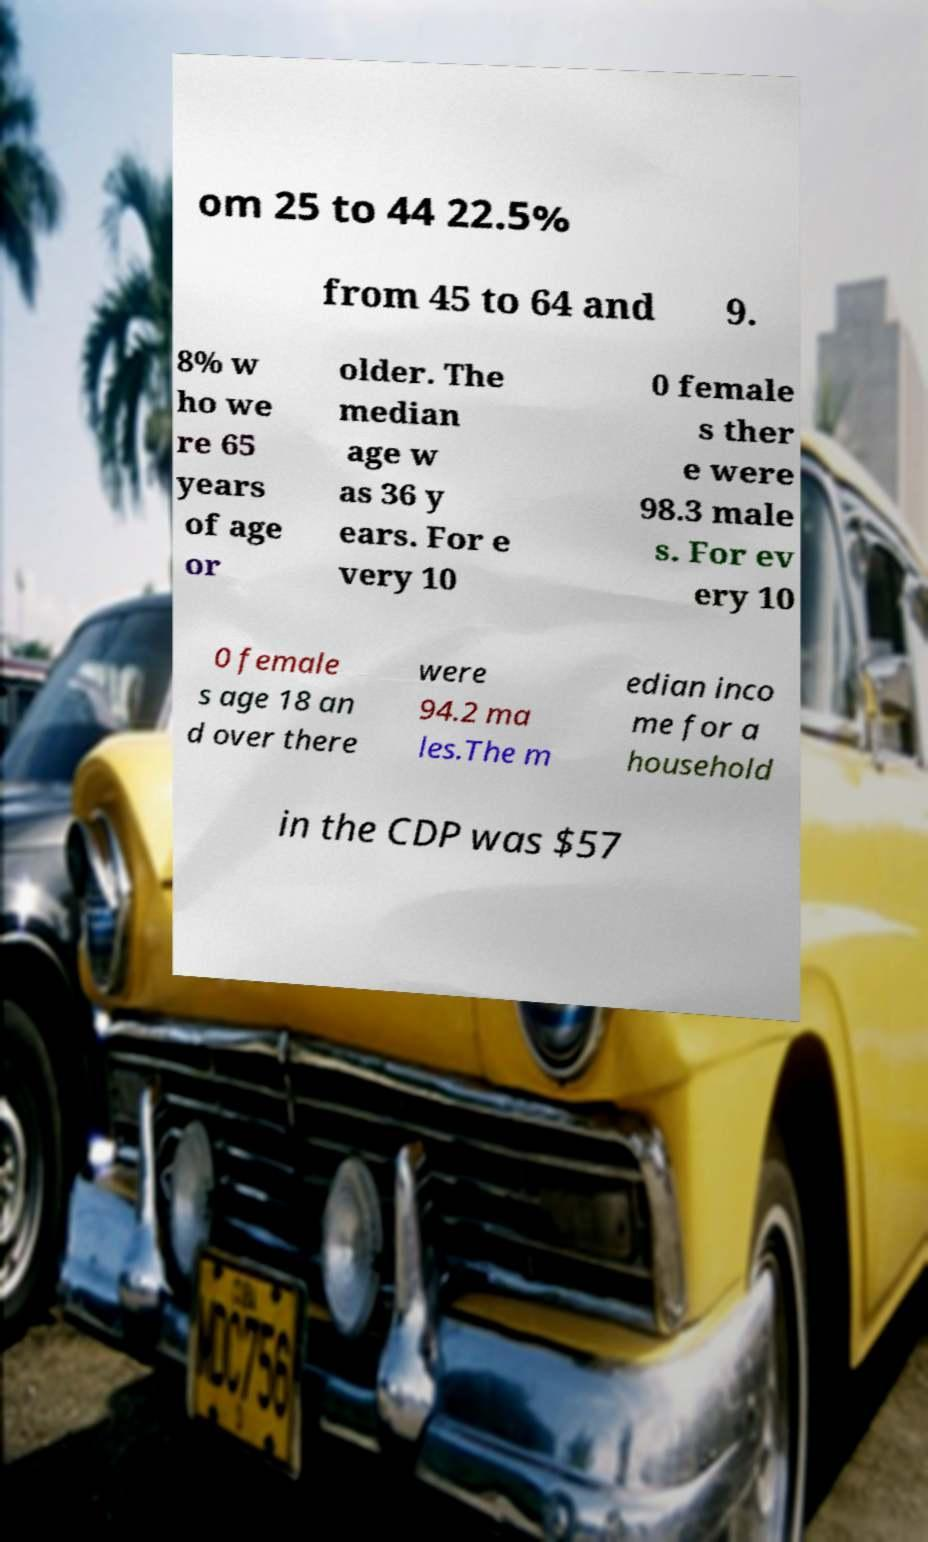Could you assist in decoding the text presented in this image and type it out clearly? om 25 to 44 22.5% from 45 to 64 and 9. 8% w ho we re 65 years of age or older. The median age w as 36 y ears. For e very 10 0 female s ther e were 98.3 male s. For ev ery 10 0 female s age 18 an d over there were 94.2 ma les.The m edian inco me for a household in the CDP was $57 